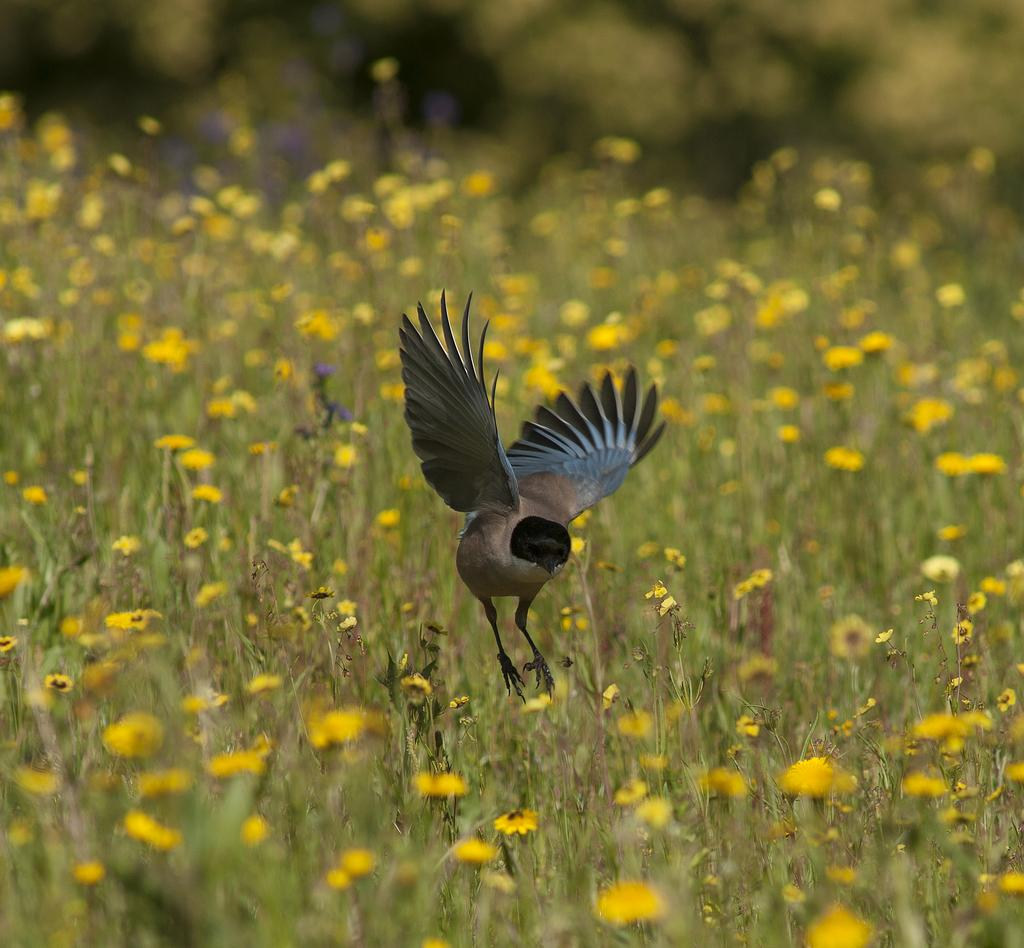What is the main subject in the center of the image? There is a bird in the center of the image. What can be seen at the bottom of the image? There are flower plants at the bottom of the image. What type of pet is visible in the frame of the image? There is no pet visible in the image, and there is no frame mentioned in the facts provided. 